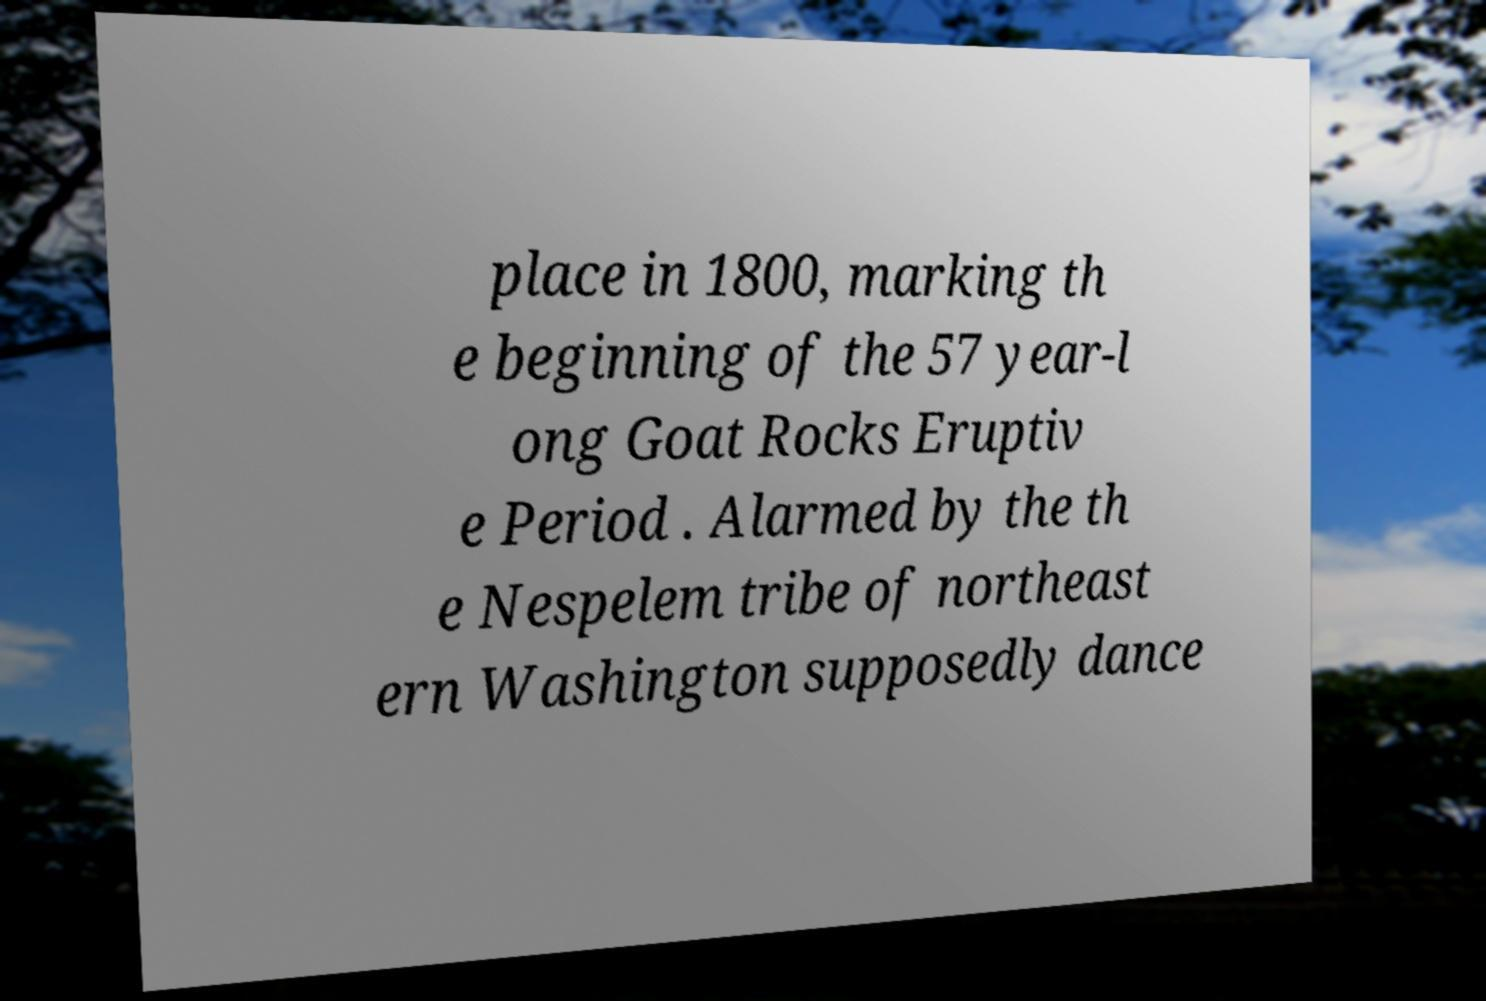Please read and relay the text visible in this image. What does it say? place in 1800, marking th e beginning of the 57 year-l ong Goat Rocks Eruptiv e Period . Alarmed by the th e Nespelem tribe of northeast ern Washington supposedly dance 